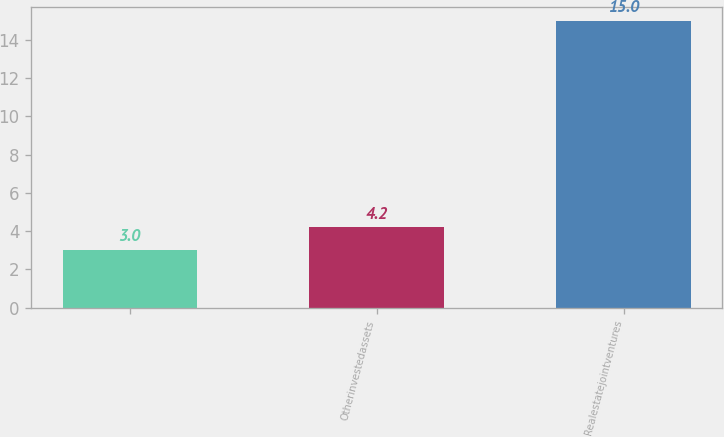Convert chart to OTSL. <chart><loc_0><loc_0><loc_500><loc_500><bar_chart><ecel><fcel>Otherinvestedassets<fcel>Realestatejointventures<nl><fcel>3<fcel>4.2<fcel>15<nl></chart> 